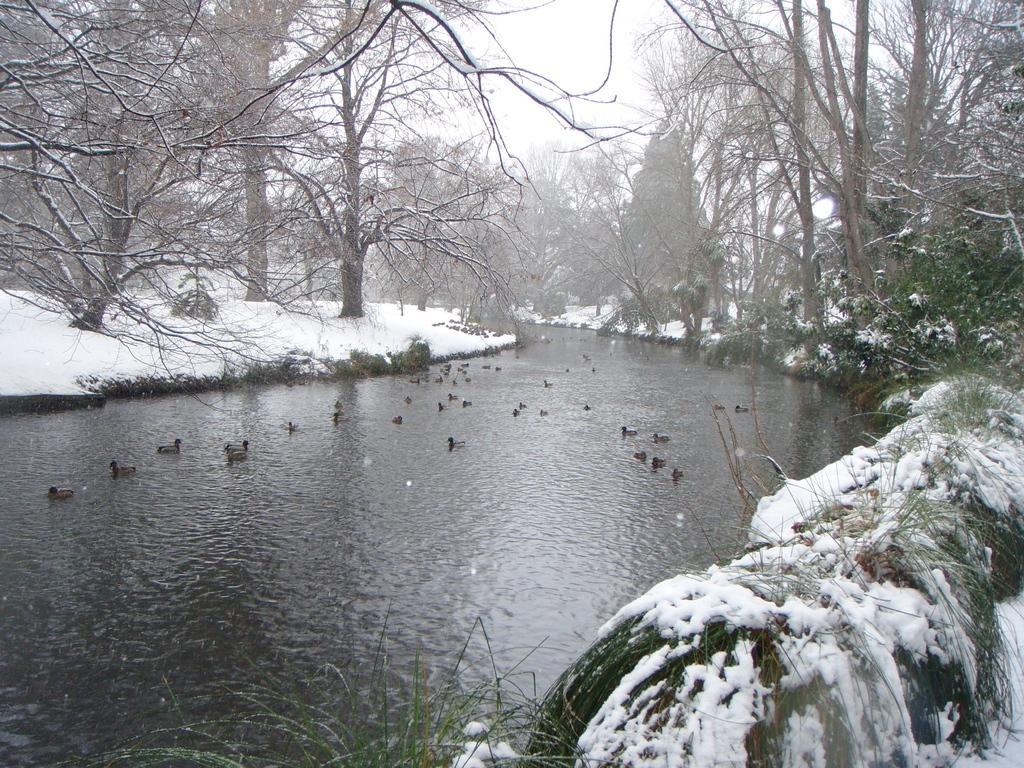How would you summarize this image in a sentence or two? In this image there is a canal in that there are ducks, on either side of the canal there is a land covered with snow and there are trees. 